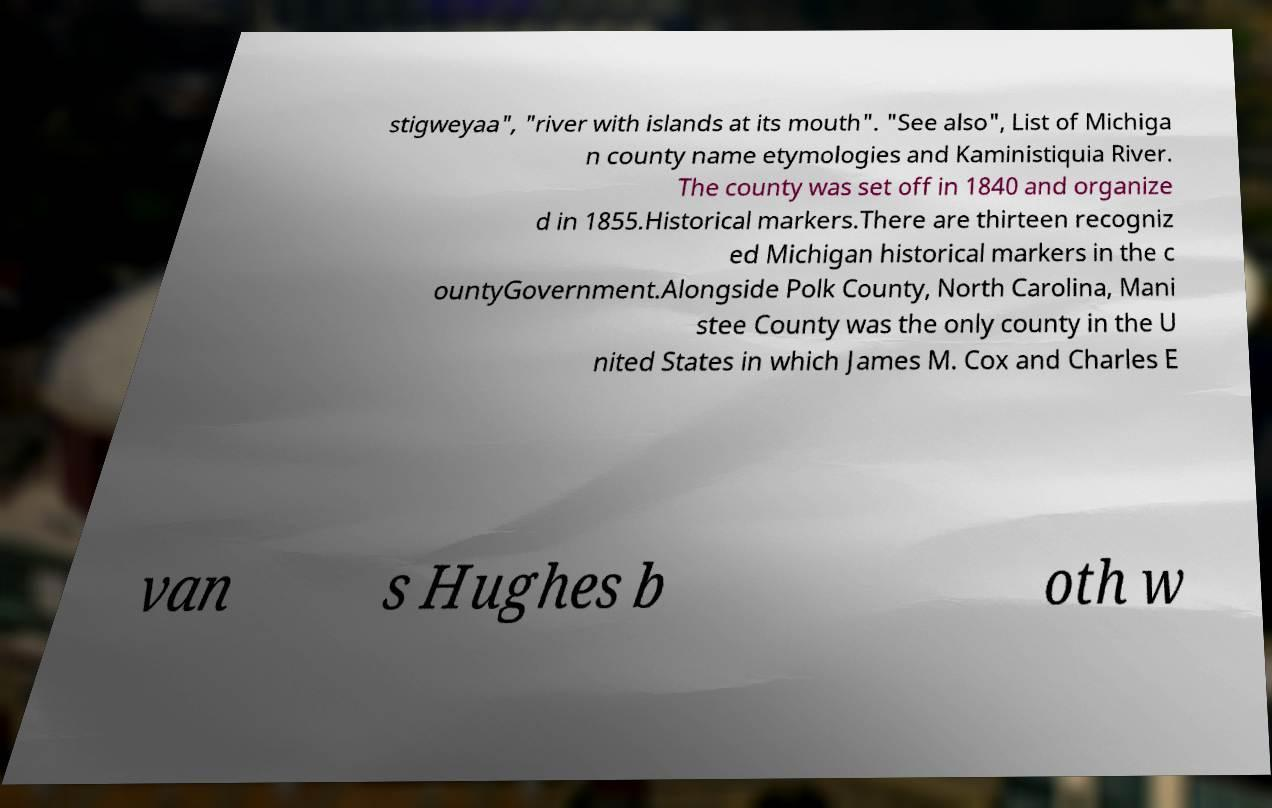Can you read and provide the text displayed in the image?This photo seems to have some interesting text. Can you extract and type it out for me? stigweyaa", "river with islands at its mouth". "See also", List of Michiga n county name etymologies and Kaministiquia River. The county was set off in 1840 and organize d in 1855.Historical markers.There are thirteen recogniz ed Michigan historical markers in the c ountyGovernment.Alongside Polk County, North Carolina, Mani stee County was the only county in the U nited States in which James M. Cox and Charles E van s Hughes b oth w 